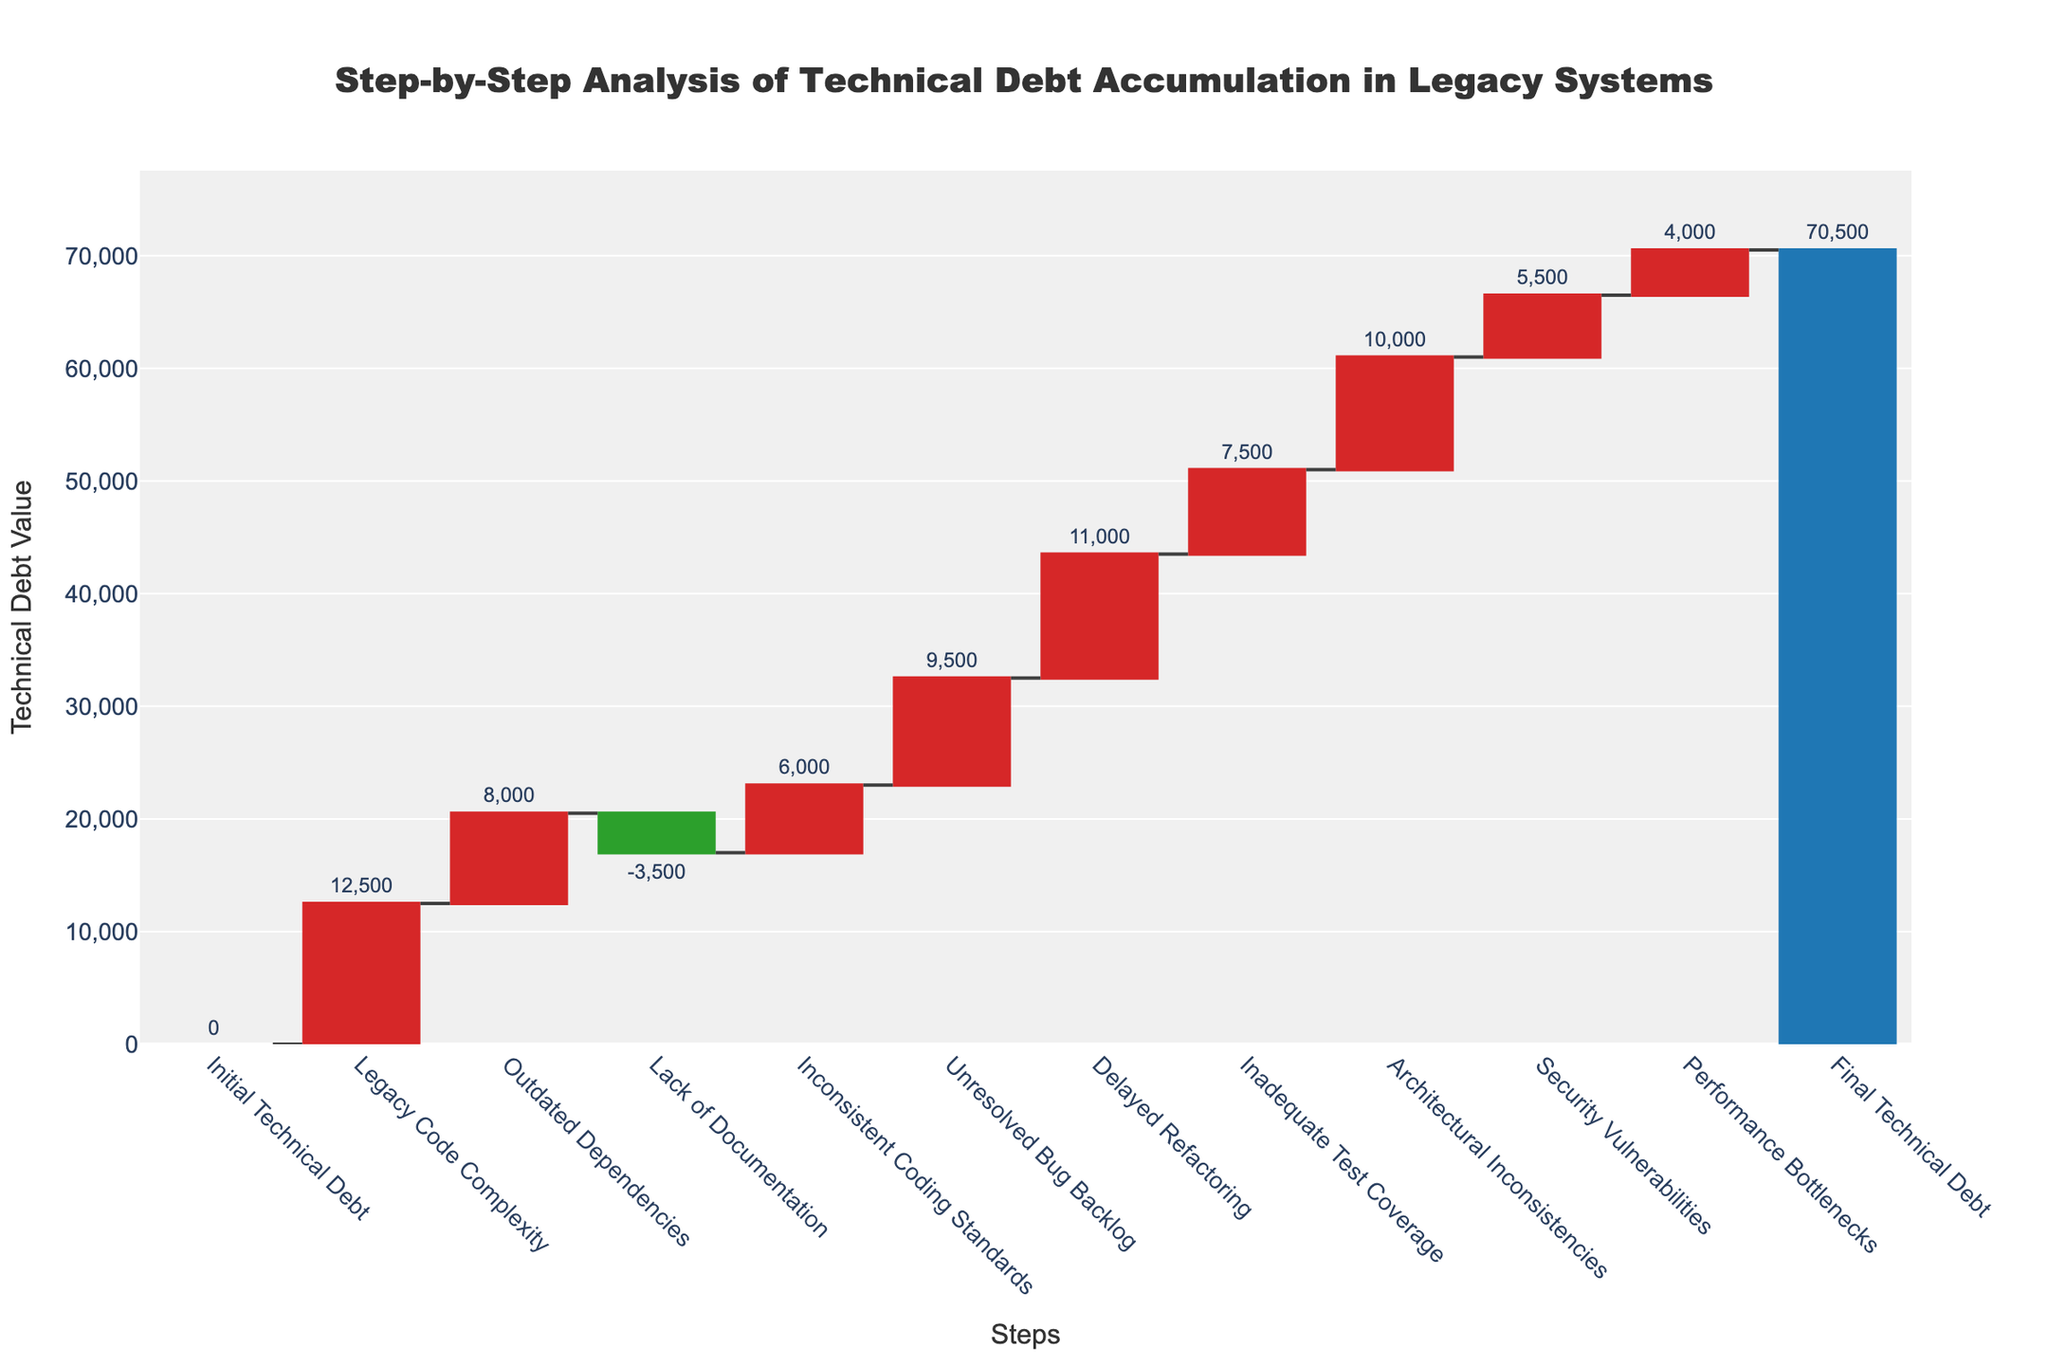What is the final technical debt value in the chart? The final technical debt value is displayed at the end of the waterfall chart under the label "Final Technical Debt" with a total value of 70,500.
Answer: 70,500 What is the step that contributes the most to technical debt? The step "Legacy Code Complexity" has the highest positive value of 12,500, indicating it contributes the most to the accumulation of technical debt.
Answer: Legacy Code Complexity How many steps reduce the technical debt? Only one step, "Lack of Documentation," has a negative effect (represented as a green bar), reducing technical debt by 3,500.
Answer: One What is the cumulative increase in technical debt from "Legacy Code Complexity" to "Unresolved Bug Backlog"? Adding the values for "Legacy Code Complexity" (12,500), "Outdated Dependencies" (8,000), "Inconsistent Coding Standards" (6,000), and "Unresolved Bug Backlog" (9,500) results in 36,000.
Answer: 36,000 How does the value of "Unresolved Bug Backlog" compare to "Inconsistent Coding Standards"? The value for "Unresolved Bug Backlog" is 9,500, which is higher than the 6,000 for "Inconsistent Coding Standards".
Answer: Unresolved Bug Backlog is higher Which step has a lower value, "Security Vulnerabilities" or "Performance Bottlenecks"? "Performance Bottlenecks" has a value of 4,000, which is lower than the value of "Security Vulnerabilities" set at 5,500.
Answer: Performance Bottlenecks What is the cumulative decrease if both "Lack of Documentation" and "Performance Bottlenecks" were resolved? Adding the negative values of "Lack of Documentation" (-3,500) and "Performance Bottlenecks" (-4,000) results in a total decrease of -7,500.
Answer: -7,500 What is the color coding for the steps that increase technical debt? The steps that increase technical debt are represented by red bars in the waterfall chart.
Answer: Red 